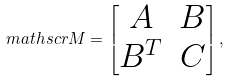Convert formula to latex. <formula><loc_0><loc_0><loc_500><loc_500>\ m a t h s c r { M } = \begin{bmatrix} A & B \\ B ^ { T } & C \end{bmatrix} ,</formula> 